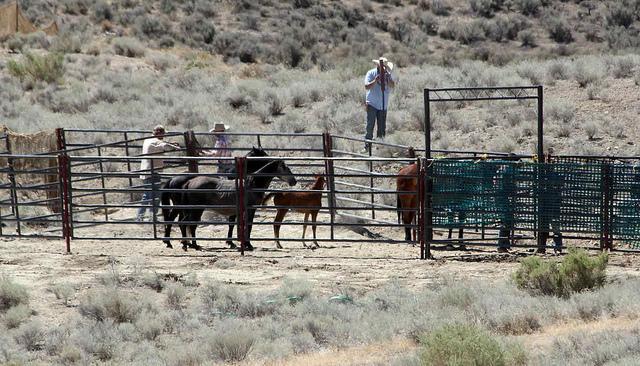How many horses are there?
Give a very brief answer. 4. 